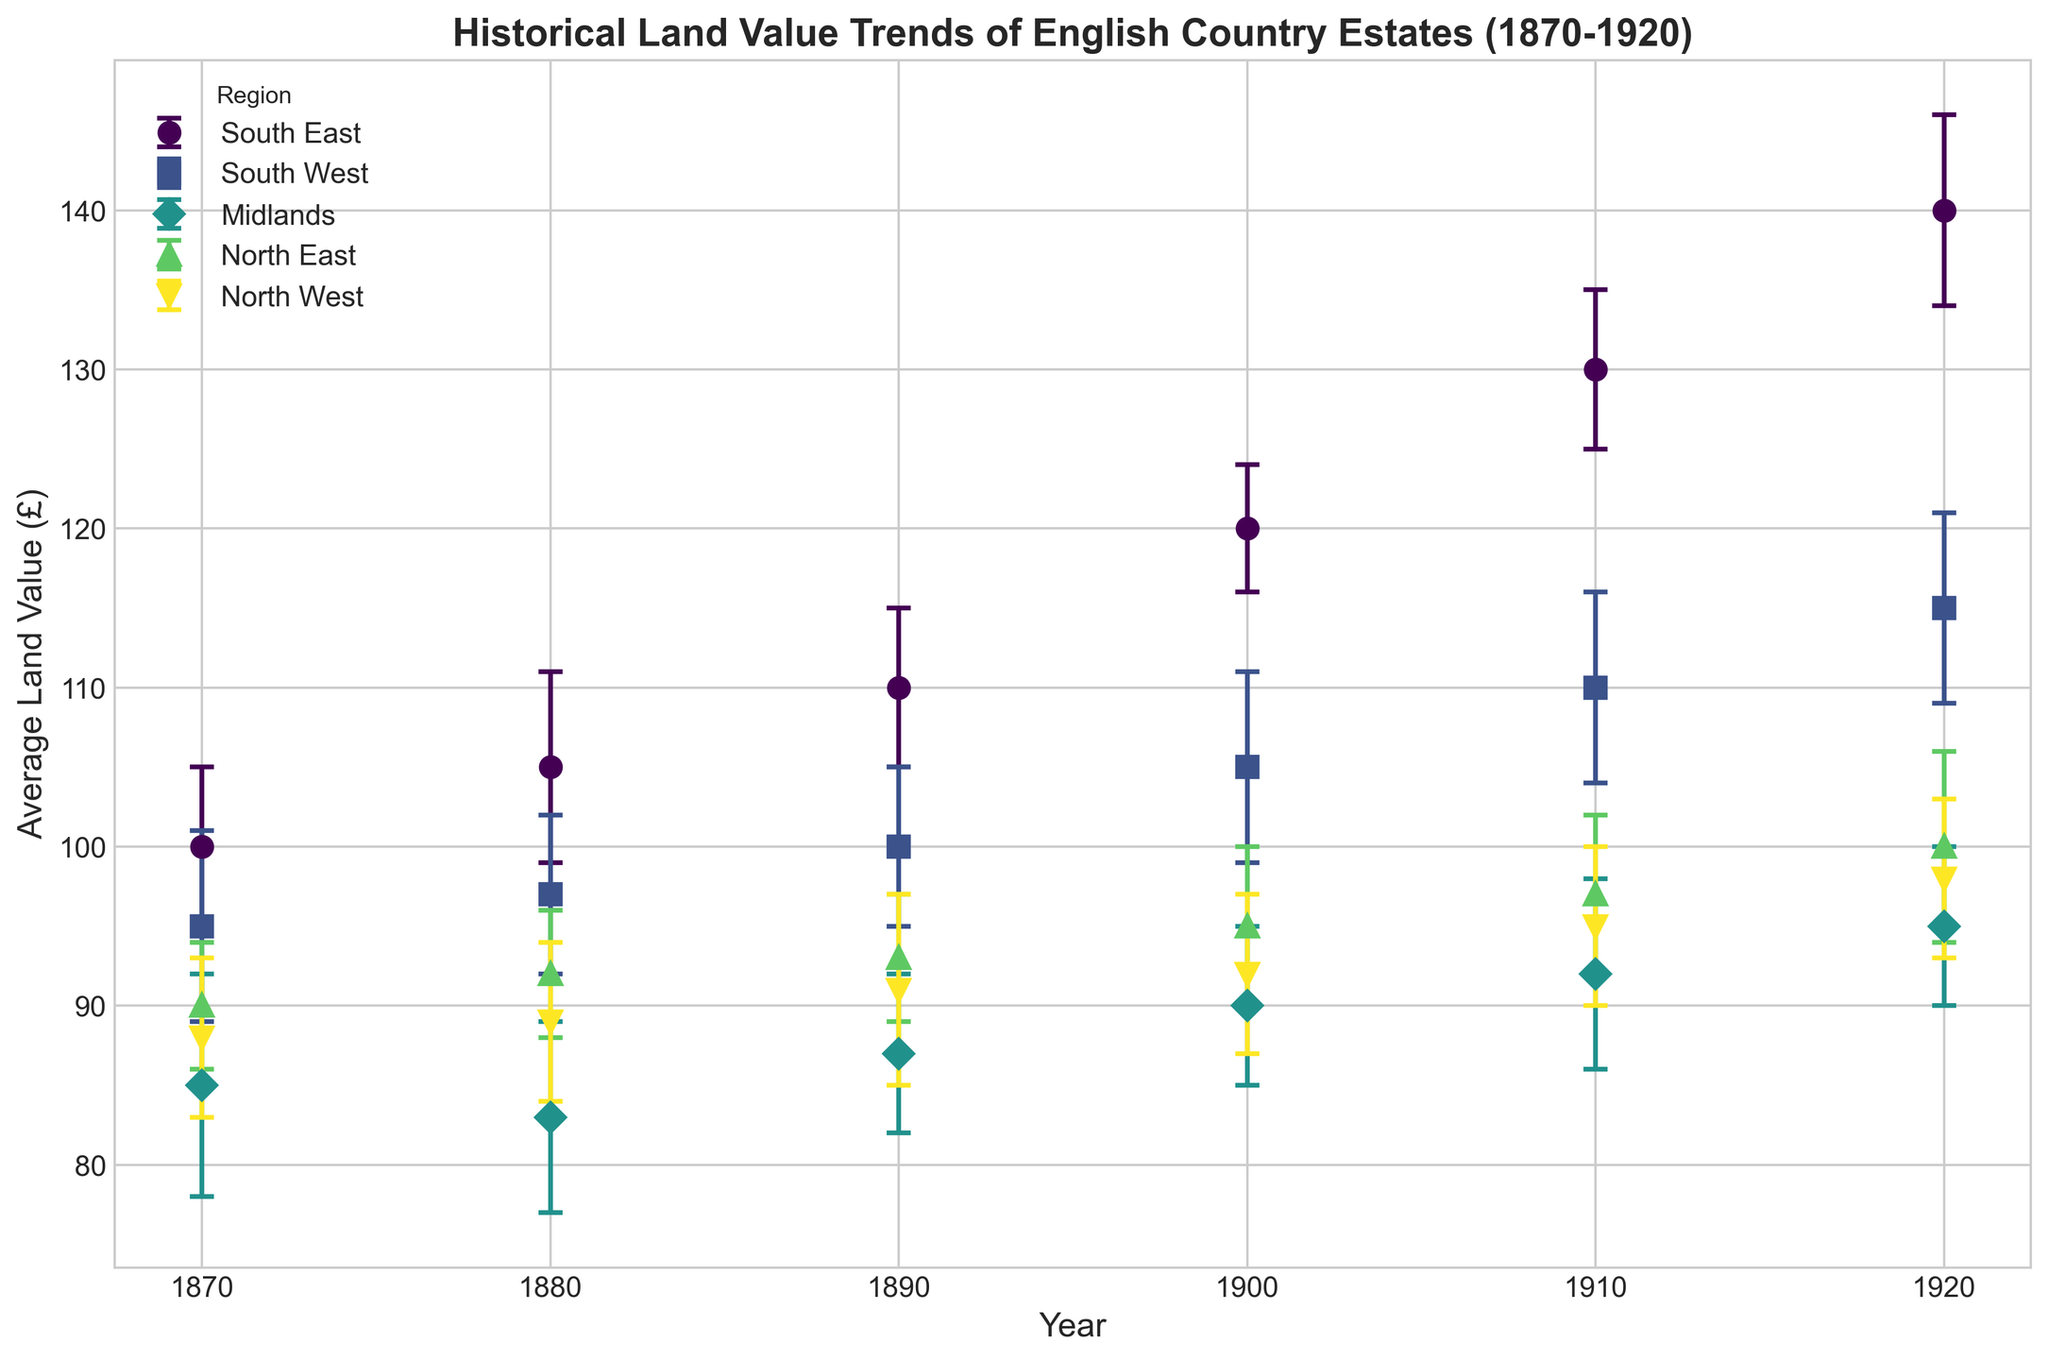Which region had the highest average land value in 1920? The South East region had the highest average land value in 1920, as indicated by the highest point on the plot for that year.
Answer: South East What is the average land value difference between the South East and the Midlands in 1870? In 1870, the average land value in the South East was £100, and in the Midlands, it was £85. The difference is calculated as £100 - £85.
Answer: £15 Which region showed the most significant increase in average land value from 1870 to 1920? By comparing the values from 1870 and 1920 for each region and calculating the differences, the South East had an increase from £100 to £140, which is a £40 increase, the highest among all regions.
Answer: South East How does the average land value in the North West in 1900 compare to that in 1910? The average land value in the North West in 1900 was £92, and in 1910, it was £95. The difference shows that it increased by £3.
Answer: It increased by £3 Which region has the narrowest range of average land values over the years? The North East region varies from £90 to £100, which is a range of £10. This is the narrowest range compared to other regions.
Answer: North East What is the combined standard deviation of the South West region's average land values in 1890 and 1920? In 1890, the standard deviation was £5, and in 1920, it was £6. The combined value is £5 + £6.
Answer: £11 Which region had the smallest increase in average land value from 1900 to 1910? The Midlands region increased from £90 to £92 from 1900 to 1910, which is an increase of £2, the smallest among all regions.
Answer: Midlands In which year did the South West region experience the largest standard deviation in its land value? By examining the error bars, the largest standard deviation for the South West was in 1870 and 1920, where it was £6.
Answer: 1870 and 1920 How did the average land value in the Midlands in 1920 compare to its value in 1870? The average land value in the Midlands was £85 in 1870 and £95 in 1920, an increase of £10.
Answer: It increased by £10 What was the standard deviation of the land value in the North East region in 1880? The plot shows the error bar for the North East region in 1880 has a standard deviation of £4.
Answer: £4 